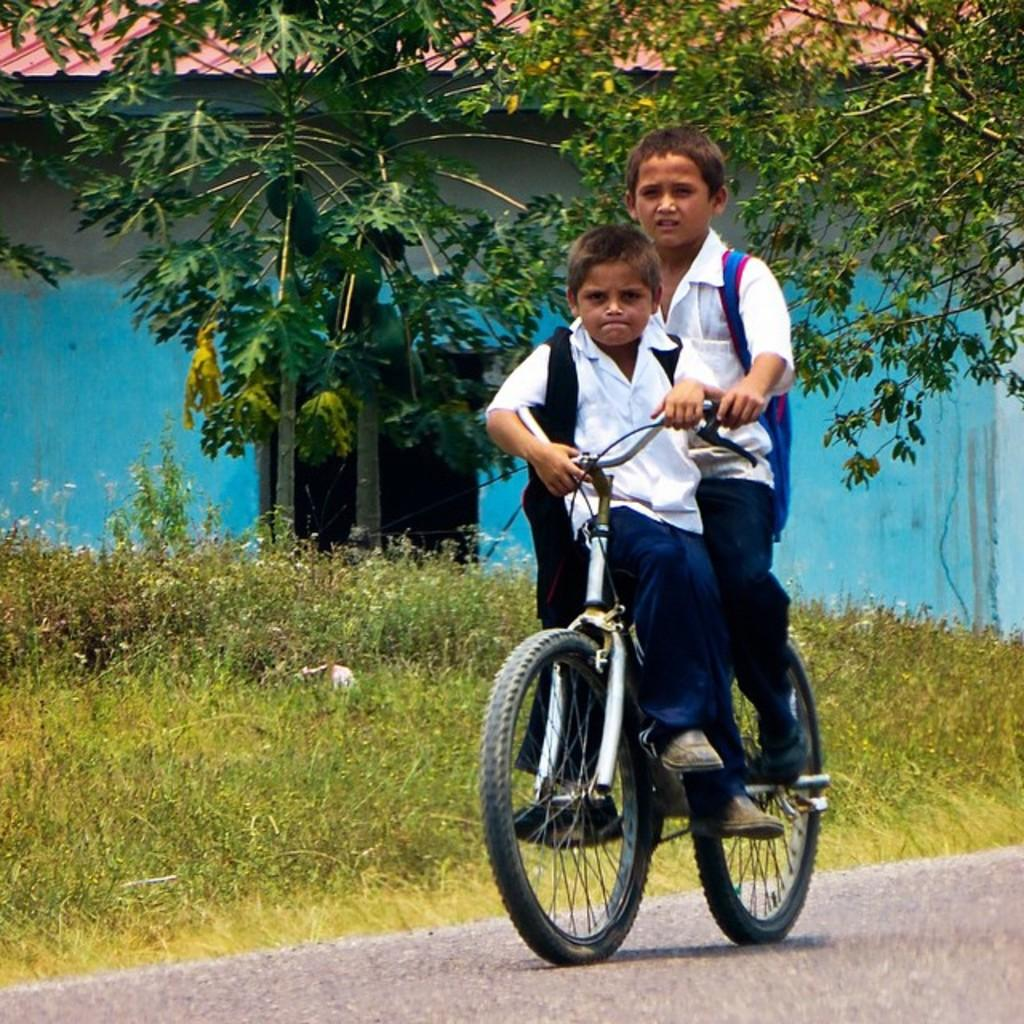How many boys are in the image? There are two boys in the image. What are the boys doing in the image? The boys are riding a bicycle. What can be seen in the background of the image? There is grass, plants, papaya trees, and a building with a roof in the background of the image. What type of nerve can be seen in the image? There is no nerve present in the image. How do the boys show respect to each other in the image? The image does not show any specific actions that indicate respect between the boys. 